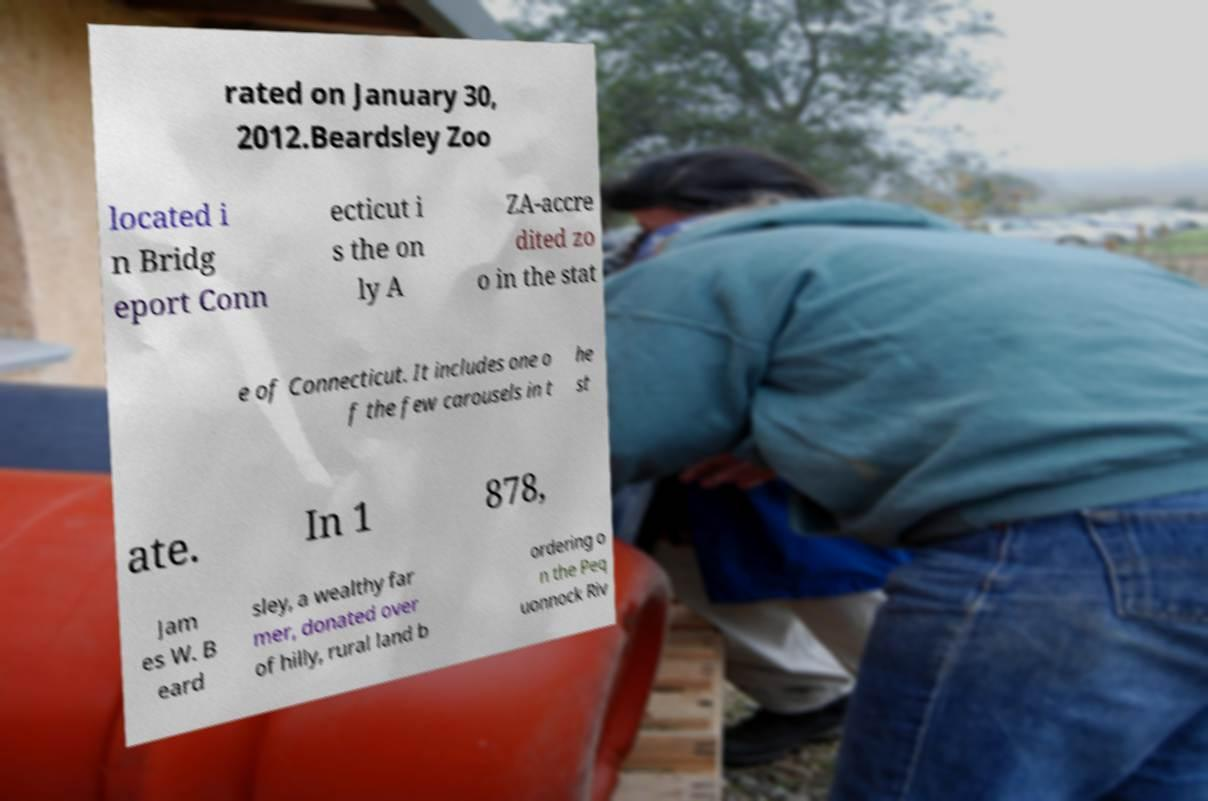Can you read and provide the text displayed in the image?This photo seems to have some interesting text. Can you extract and type it out for me? rated on January 30, 2012.Beardsley Zoo located i n Bridg eport Conn ecticut i s the on ly A ZA-accre dited zo o in the stat e of Connecticut. It includes one o f the few carousels in t he st ate. In 1 878, Jam es W. B eard sley, a wealthy far mer, donated over of hilly, rural land b ordering o n the Peq uonnock Riv 